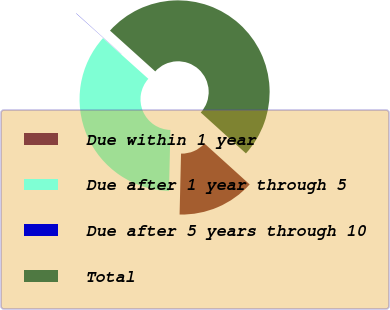Convert chart to OTSL. <chart><loc_0><loc_0><loc_500><loc_500><pie_chart><fcel>Due within 1 year<fcel>Due after 1 year through 5<fcel>Due after 5 years through 10<fcel>Total<nl><fcel>13.67%<fcel>36.26%<fcel>0.04%<fcel>50.02%<nl></chart> 